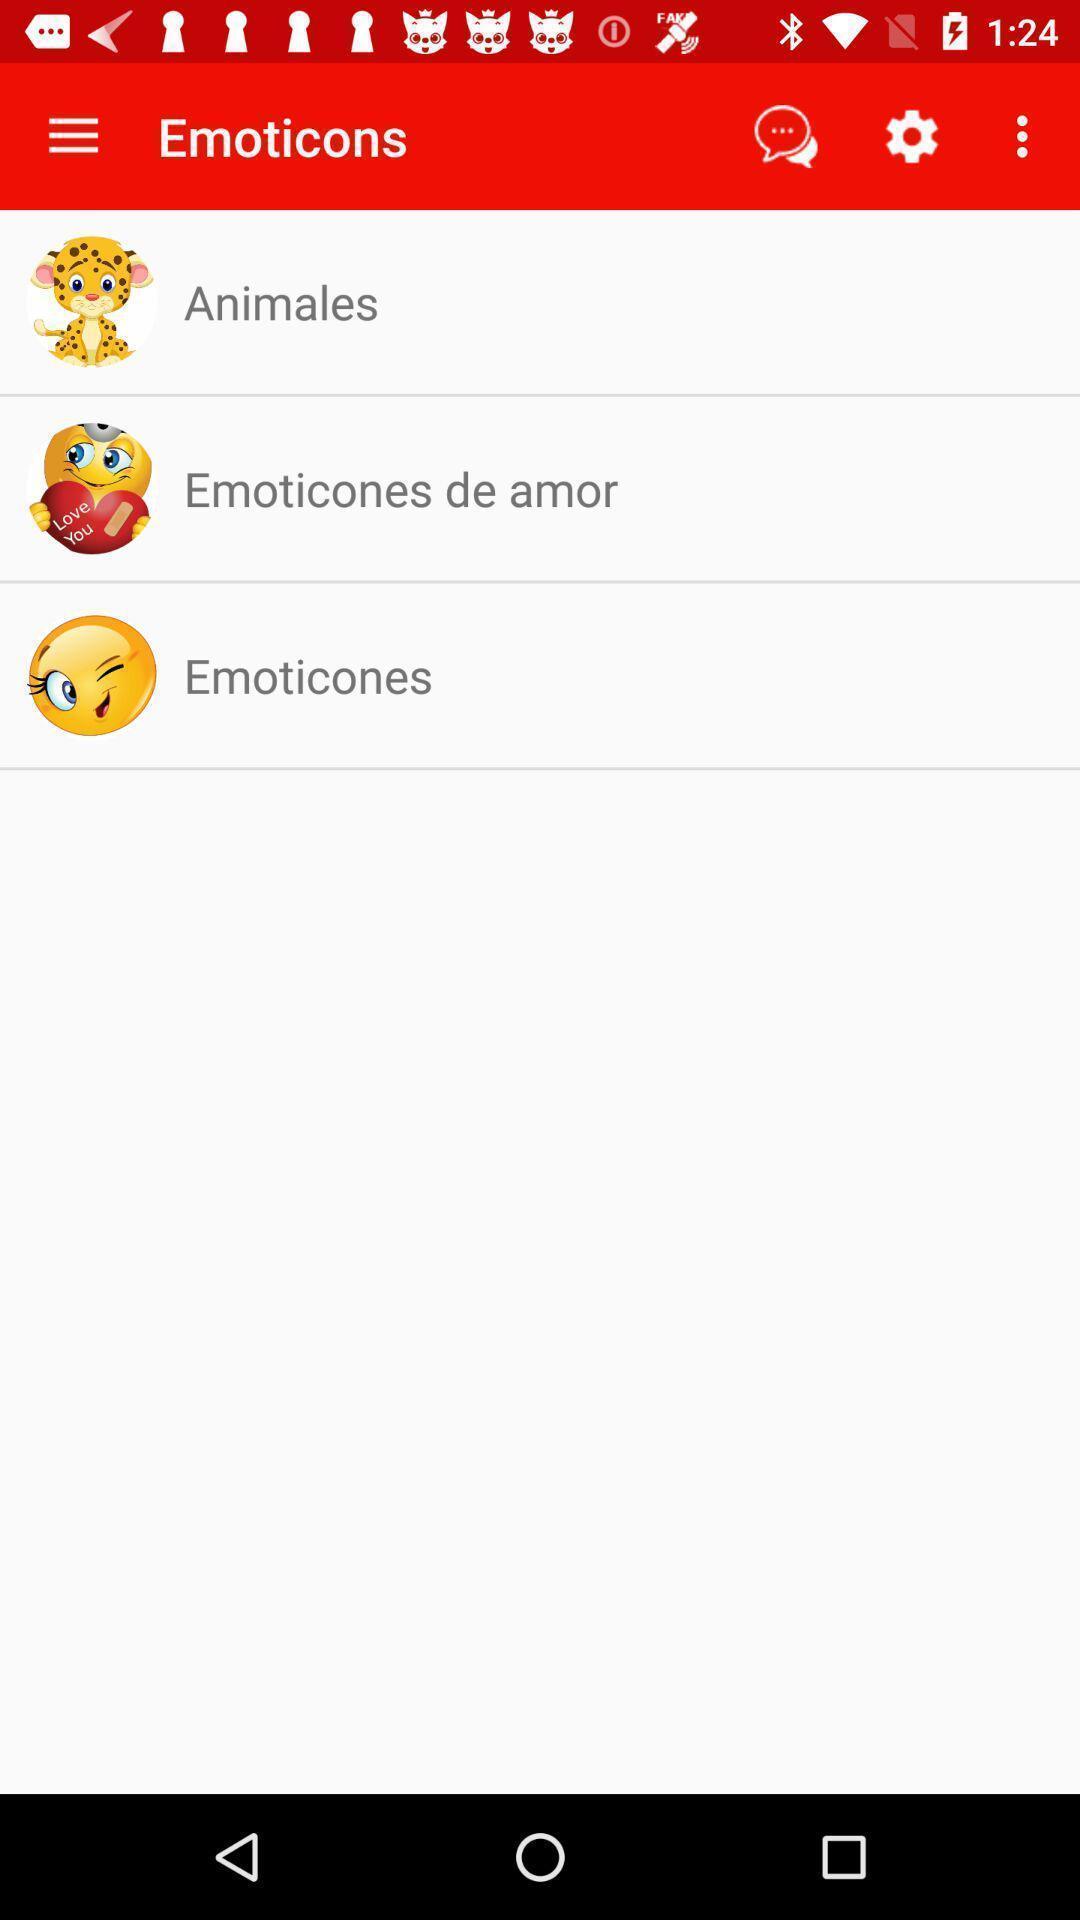Summarize the main components in this picture. Page displaying the list of emojis categories. 